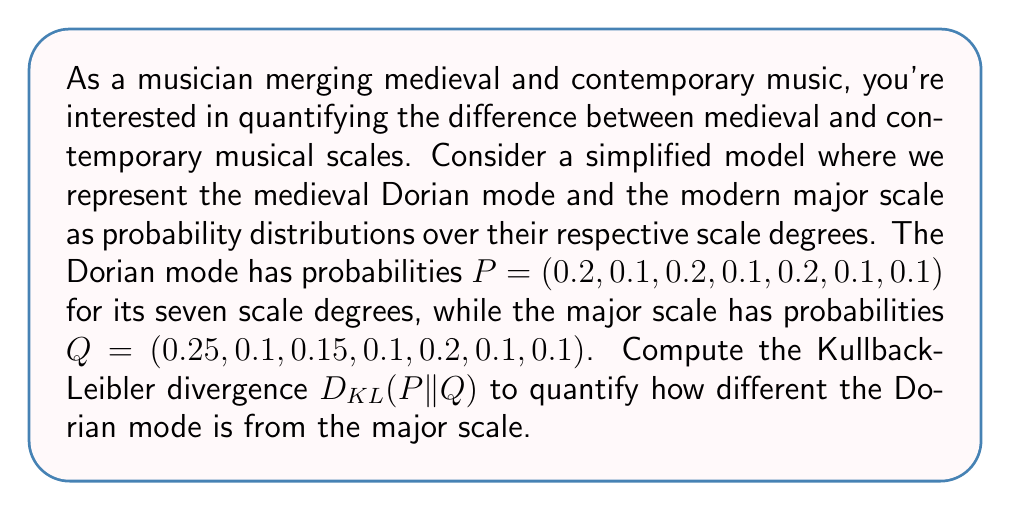Can you solve this math problem? To solve this problem, we'll follow these steps:

1) The Kullback-Leibler divergence is defined as:

   $$D_{KL}(P||Q) = \sum_{i} P(i) \log \frac{P(i)}{Q(i)}$$

2) We'll calculate this sum for each of the seven scale degrees:

   For i = 1: $0.2 \log \frac{0.2}{0.25} = 0.2 \log 0.8 = -0.0458$
   For i = 2: $0.1 \log \frac{0.1}{0.1} = 0$
   For i = 3: $0.2 \log \frac{0.2}{0.15} = 0.2 \log 1.3333 = 0.0575$
   For i = 4: $0.1 \log \frac{0.1}{0.1} = 0$
   For i = 5: $0.2 \log \frac{0.2}{0.2} = 0$
   For i = 6: $0.1 \log \frac{0.1}{0.1} = 0$
   For i = 7: $0.1 \log \frac{0.1}{0.1} = 0$

3) Sum all these values:

   $D_{KL}(P||Q) = -0.0458 + 0 + 0.0575 + 0 + 0 + 0 + 0 = 0.0117$

The Kullback-Leibler divergence from the Dorian mode to the major scale is approximately 0.0117 bits.
Answer: 0.0117 bits 